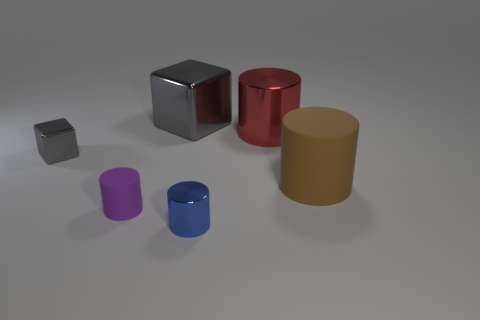Subtract all big red cylinders. How many cylinders are left? 3 Subtract all brown cylinders. How many cylinders are left? 3 Add 3 big green metallic balls. How many objects exist? 9 Subtract 1 cubes. How many cubes are left? 1 Subtract all cylinders. How many objects are left? 2 Subtract all brown cylinders. Subtract all red balls. How many cylinders are left? 3 Subtract all yellow cylinders. How many red blocks are left? 0 Subtract all brown objects. Subtract all big gray shiny cubes. How many objects are left? 4 Add 1 large red things. How many large red things are left? 2 Add 3 matte objects. How many matte objects exist? 5 